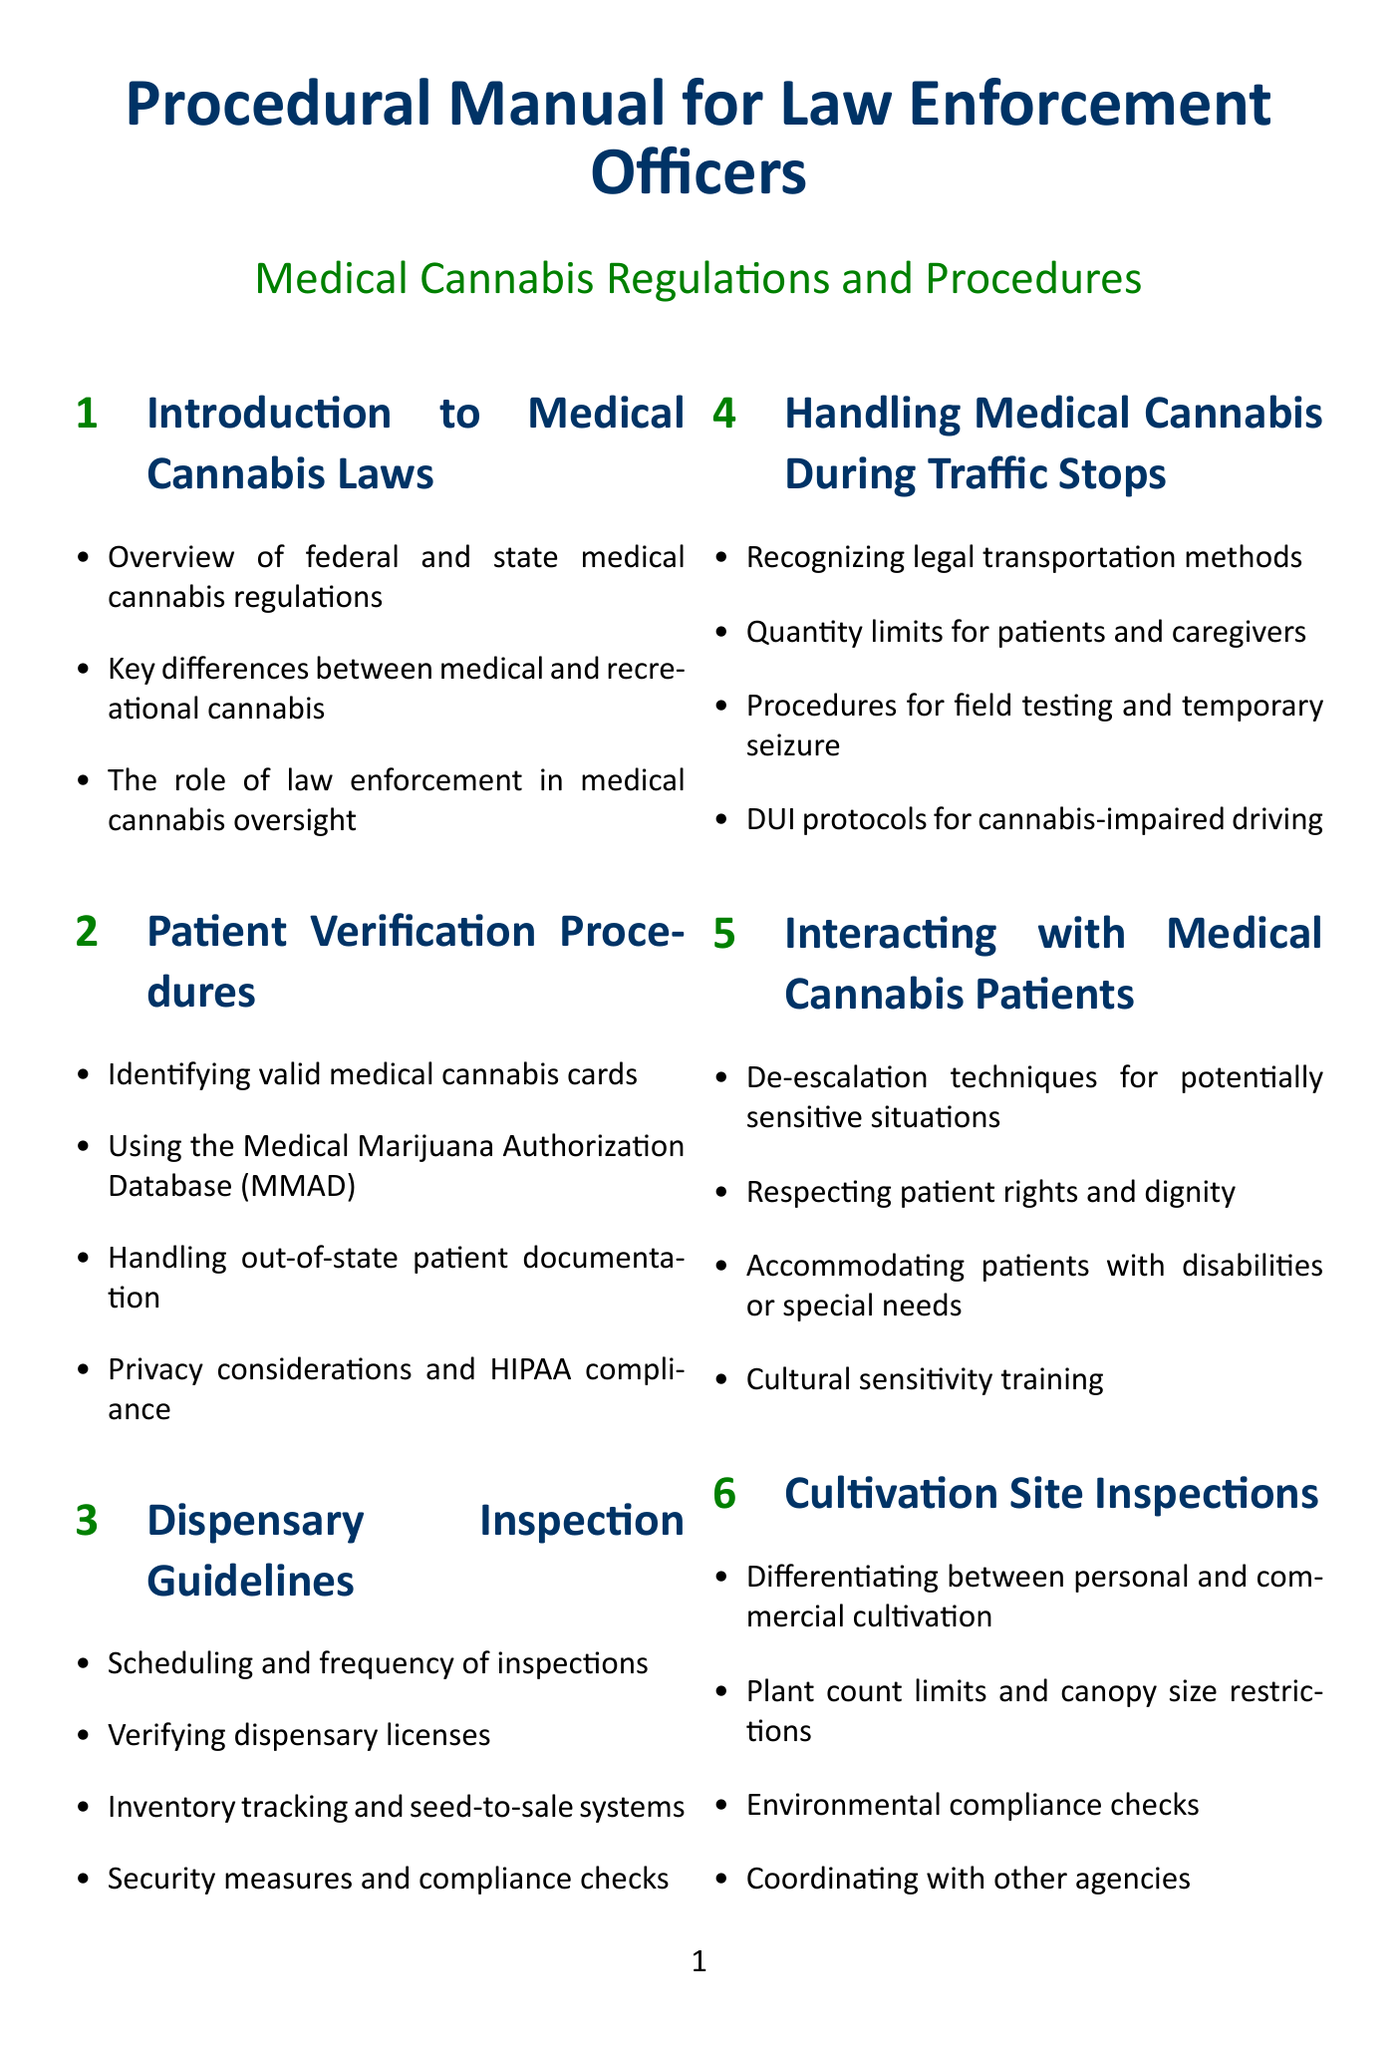What is the main purpose of the manual? The manual serves to provide procedural guidelines for law enforcement officers regarding medical cannabis laws and regulations.
Answer: Procedural guidelines What database is used for patient verification? The Medical Marijuana Authorization Database (MMAD) is mentioned as a tool for verifying patient eligibility.
Answer: MMAD How many sections does the manual contain? The manual includes ten distinct sections covering various aspects of medical cannabis handling and enforcement.
Answer: Ten What are the privacy considerations mentioned in relation to patient verification? The manual highlights HIPAA compliance as a critical consideration in managing patient information.
Answer: HIPAA compliance What is a key responsibility of law enforcement in medical cannabis oversight? One significant responsibility is the verification of dispensary licenses to ensure compliance with regulations.
Answer: Verification of dispensary licenses What is the title of Section 6? The title of Section 6 is "Evidence Handling and Chain of Custody."
Answer: Evidence Handling and Chain of Custody What is required during dispensary inspections regarding inventory? Inventory tracking and seed-to-sale systems must be verified during inspections.
Answer: Seed-to-sale systems How should law enforcement handle a situation with a medical cannabis patient? The manual recommends using de-escalation techniques to manage sensitive encounters effectively.
Answer: De-escalation techniques What should officers do with cannabis evidence post-seizure? Officers are instructed to follow specific documentation procedures for seizures and returns of cannabis evidence.
Answer: Documentation procedures What kind of training is suggested for law enforcement officers? Cultural sensitivity training is recommended to better interact with medical cannabis patients.
Answer: Cultural sensitivity training 